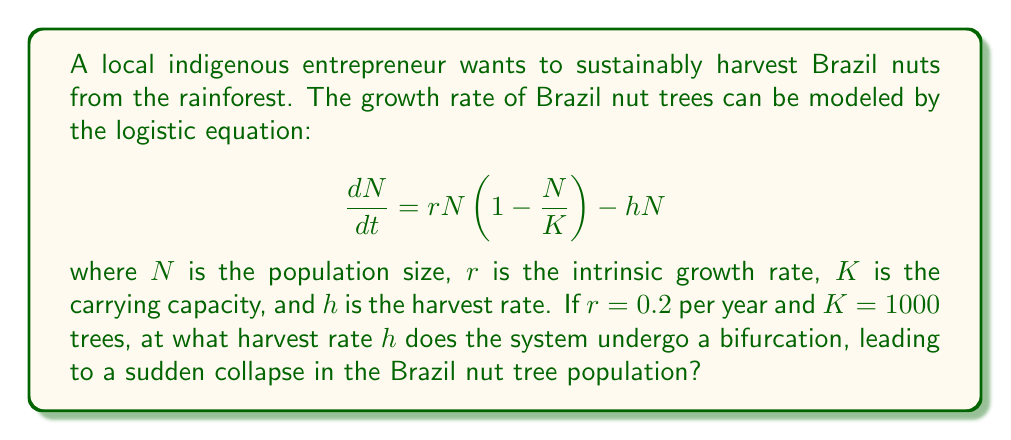Could you help me with this problem? To find the bifurcation point, we need to follow these steps:

1) First, we find the equilibrium points by setting $\frac{dN}{dt} = 0$:

   $$0 = rN(1 - \frac{N}{K}) - hN$$

2) Factoring out $N$:

   $$0 = N(r(1 - \frac{N}{K}) - h)$$

3) This equation is satisfied when $N = 0$ or when $r(1 - \frac{N}{K}) - h = 0$

4) Solving the second equation for $N$:

   $$N = K(1 - \frac{h}{r})$$

5) The bifurcation occurs when this equilibrium point becomes negative, i.e., when:

   $$K(1 - \frac{h}{r}) < 0$$

6) Solving this inequality:

   $$1 - \frac{h}{r} < 0$$
   $$\frac{h}{r} > 1$$
   $$h > r$$

7) Therefore, the bifurcation occurs when $h = r = 0.2$ per year.

This is the point at which the sustainable equilibrium disappears, leading to a sudden collapse in the population if the harvest rate exceeds this value.
Answer: $h = 0.2$ per year 